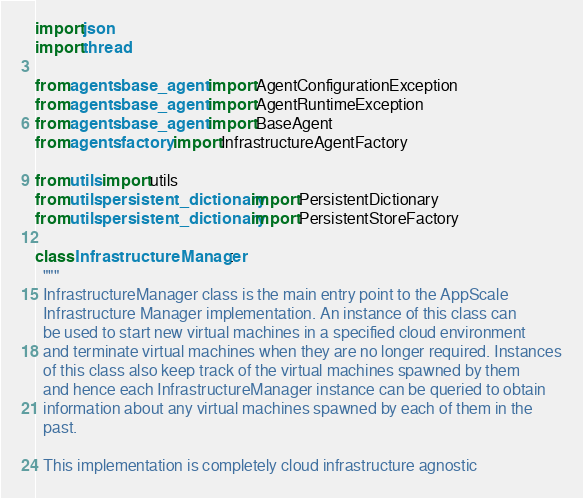<code> <loc_0><loc_0><loc_500><loc_500><_Python_>import json
import thread

from agents.base_agent import AgentConfigurationException
from agents.base_agent import AgentRuntimeException
from agents.base_agent import BaseAgent
from agents.factory import InfrastructureAgentFactory

from utils import utils
from utils.persistent_dictionary import PersistentDictionary
from utils.persistent_dictionary import PersistentStoreFactory

class InfrastructureManager:
  """
  InfrastructureManager class is the main entry point to the AppScale
  Infrastructure Manager implementation. An instance of this class can
  be used to start new virtual machines in a specified cloud environment
  and terminate virtual machines when they are no longer required. Instances
  of this class also keep track of the virtual machines spawned by them
  and hence each InfrastructureManager instance can be queried to obtain
  information about any virtual machines spawned by each of them in the
  past.

  This implementation is completely cloud infrastructure agnostic</code> 